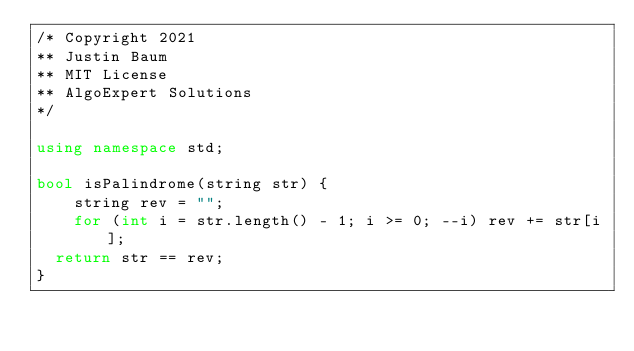<code> <loc_0><loc_0><loc_500><loc_500><_C++_>/* Copyright 2021
** Justin Baum
** MIT License
** AlgoExpert Solutions
*/

using namespace std;

bool isPalindrome(string str) {
    string rev = "";
    for (int i = str.length() - 1; i >= 0; --i) rev += str[i];
  return str == rev;
}
</code> 